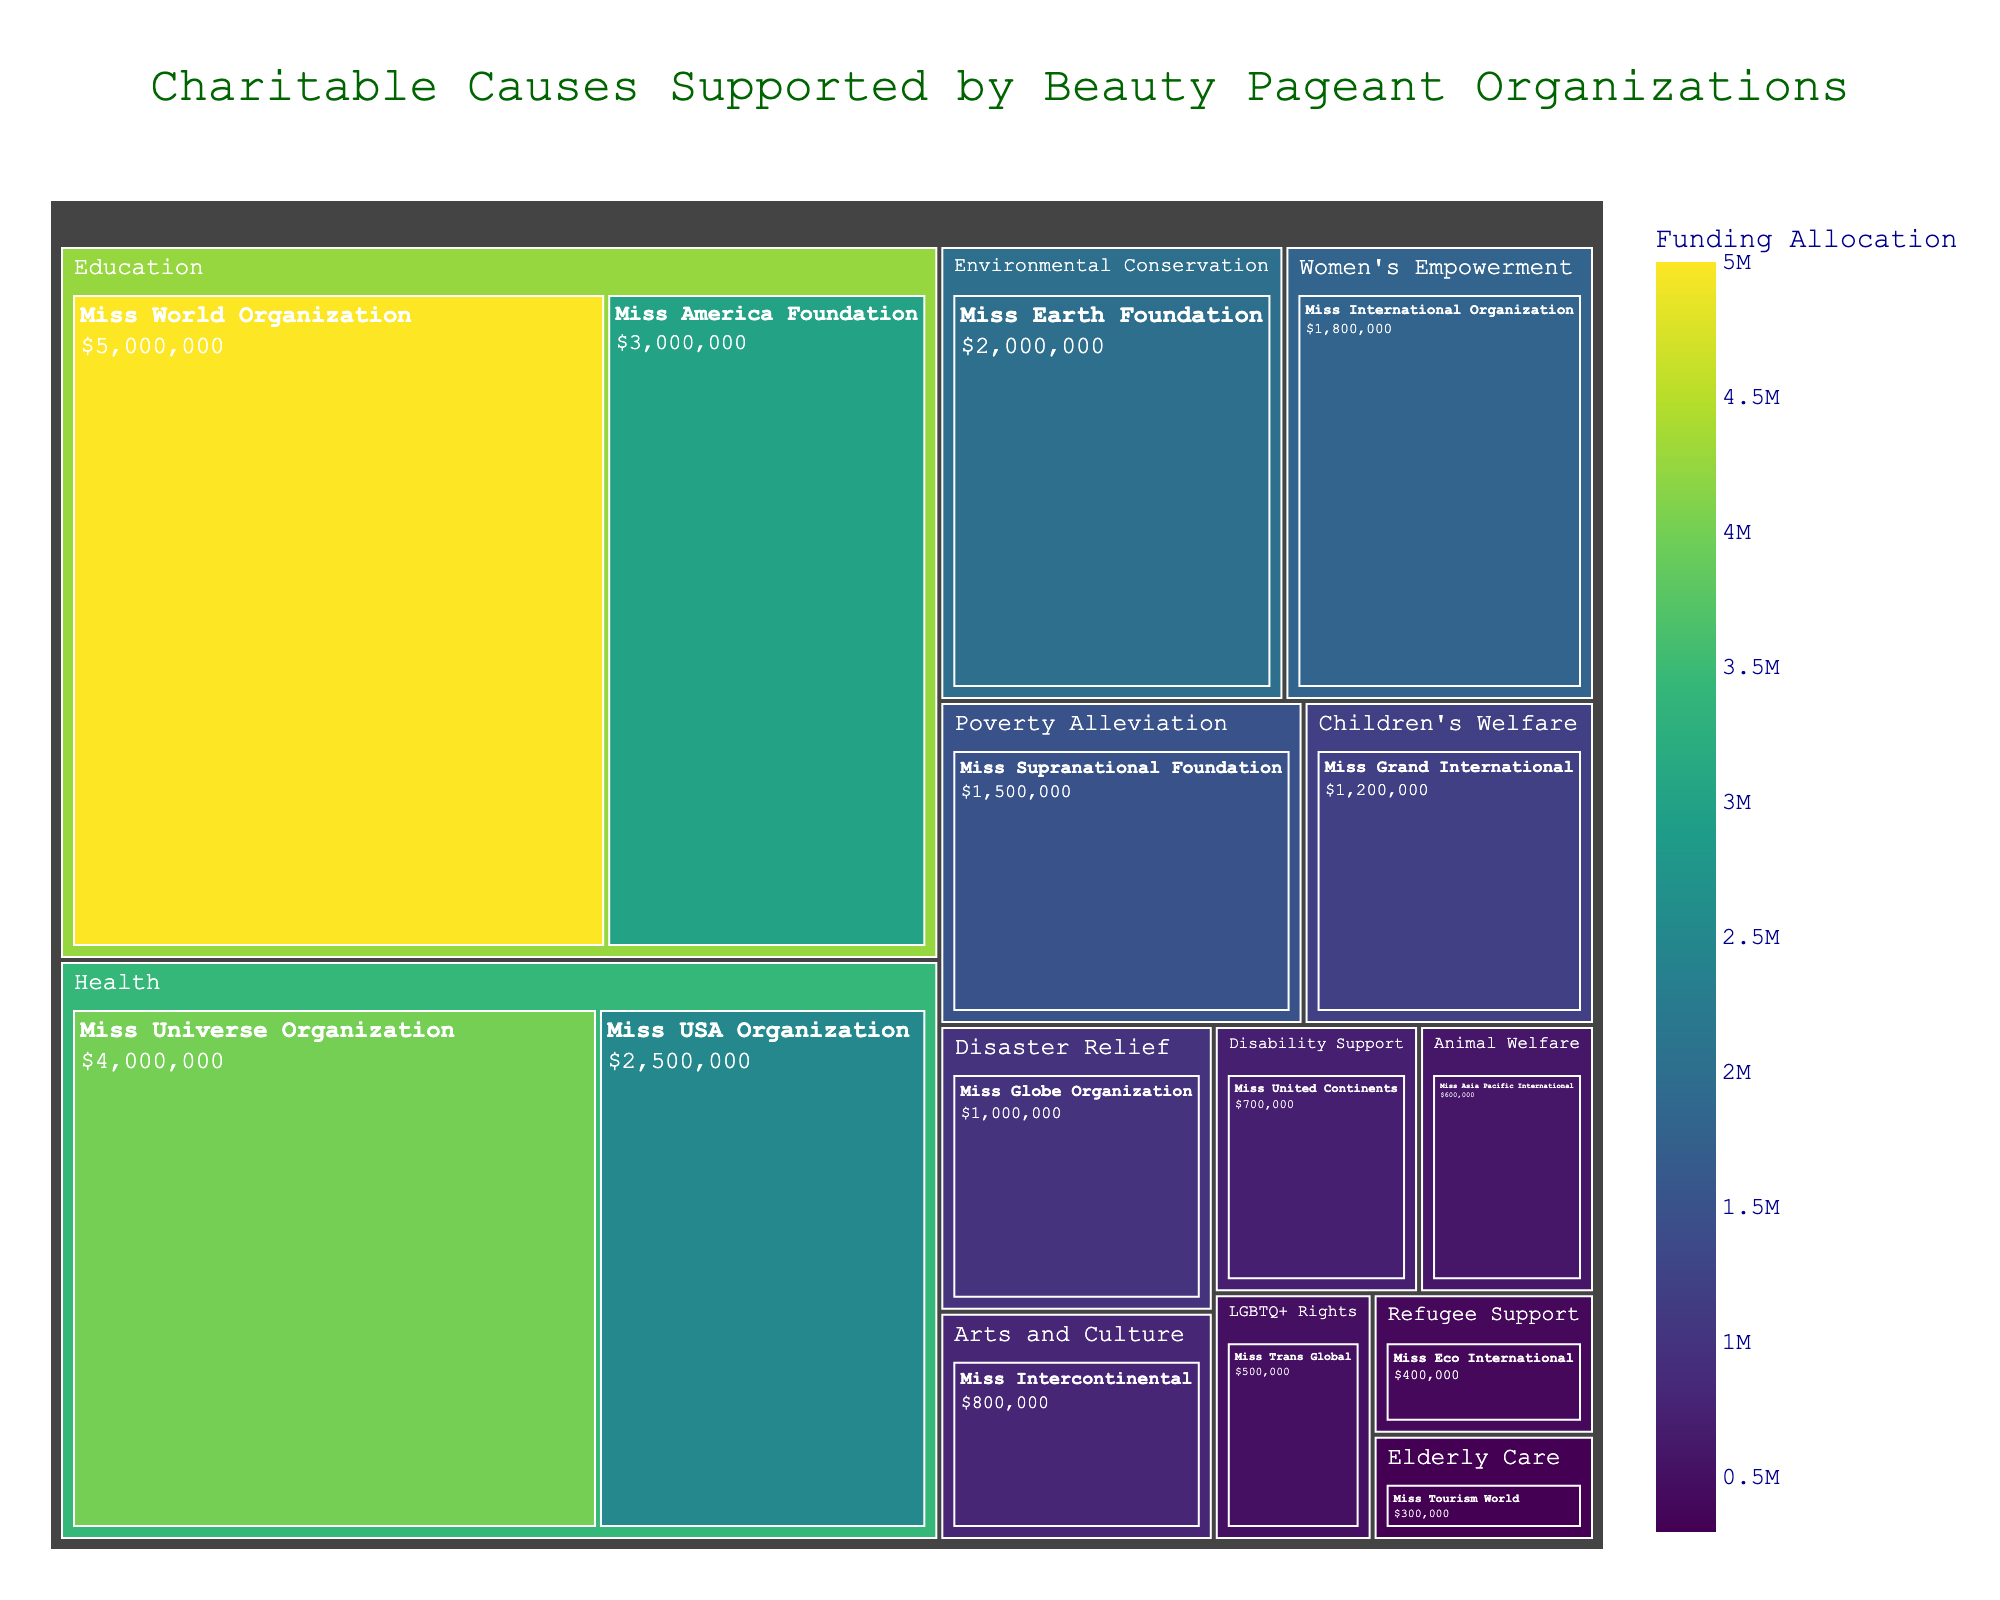How many organizations are categorized under "Health"? Look at the treemap section labeled "Health" and count the number of subdivisions within it. Each subdivision represents an organization.
Answer: 2 Which focus area received the highest funding allocation? Identify the largest section in size on the treemap, which represents the focus area with the highest funding allocation.
Answer: Education What is the total funding allocation for organizations focused on Education? Sum the funding allocations for all organizations under the "Education" category. From the treemap, add the allocations for Miss World Organization ($5,000,000) and Miss America Foundation ($3,000,000).
Answer: $8,000,000 Compare the funding allocations for the "Health" and "Women's Empowerment" focus areas. Which one has more, and by how much? First, find the total funding for "Health" ($4,000,000 + $2,500,000 = $6,500,000). Then, find the funding for "Women's Empowerment" ($1,800,000). Subtract to find the difference.
Answer: Health has more, by $4,700,000 Which organization has the smallest funding allocation, and what is its focus area? Identify the smallest section representing funding allocation in the treemap. This section is colored the darkest (based on the continuous color scale used).
Answer: Miss Tourism World, Elderly Care, $300,000 What percentage of total funding is allocated to the "Disaster Relief" focus area? To find this, divide the funding for "Disaster Relief" ($1,000,000) by the total funding across all focus areas. Sum all funding allocations from the data (total = $25,500,000), then apply the division and multiply by 100.
Answer: Approximately 3.92% What is the difference in funding between "Environmental Conservation" and "Disability Support"? Note the funding for "Environmental Conservation" ($2,000,000) and for "Disability Support" ($700,000). Subtract the smaller from the larger.
Answer: $1,300,000 How many organizations have a funding allocation of $1,000,000 or less? Count the subdivisions in the treemap that have a funding value of $1,000,000 or below.
Answer: 6 Which organization under the "Children's Welfare" focus area, and what is its funding allocation? Check the "Children's Welfare" category in the treemap and note the organization and its funding detailed within that section.
Answer: Miss Grand International, $1,200,000 How does the treemap represent different funding allocations? Look at the size and the color of the sections within the treemap. Larger sections represent higher funding allocations, while the color gradient (in this case, Viridis scale) helps differentiate funding values, with the darkest color representing the smallest funding.
Answer: By size and color 